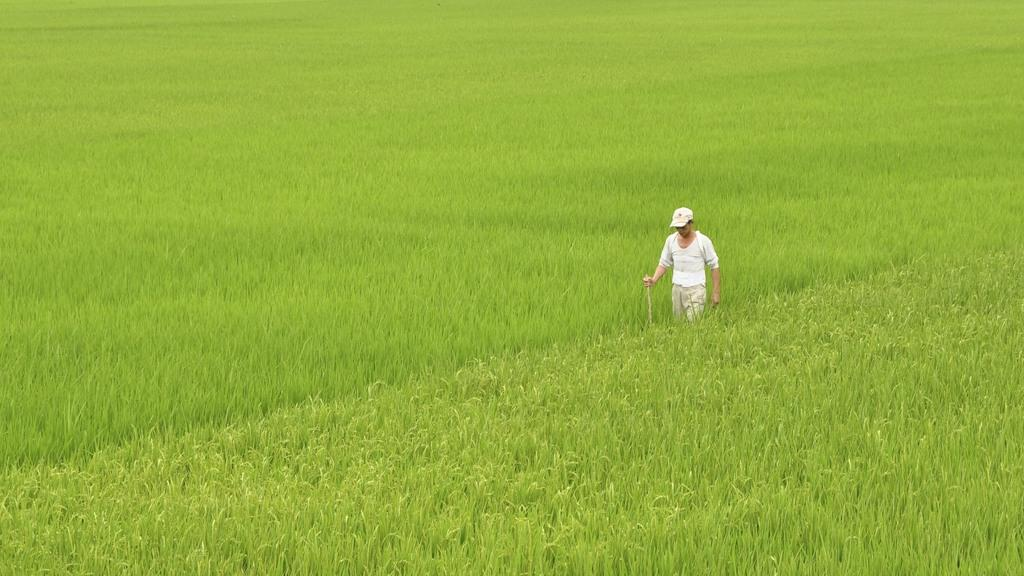Who is the main subject in the image? There is a man in the image. Where is the man located in the image? The man is in the middle of the image. What is the man wearing on his upper body? The man is wearing a white t-shirt. What type of headwear is the man wearing? The man is wearing a cap. What can be seen in the background of the image? There is a crop visible in the image. What type of lock is used to secure the dinner in the image? There is no lock or dinner present in the image; it features a man wearing a white t-shirt and cap, with a crop visible in the background. 